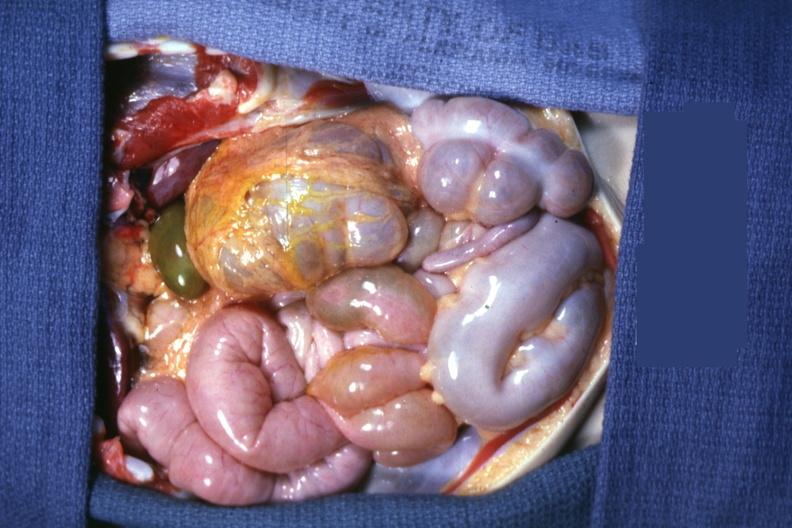s situs inversus present?
Answer the question using a single word or phrase. Yes 